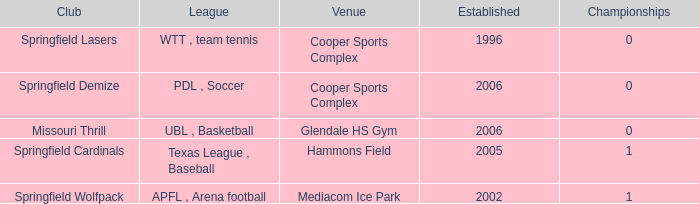What are the highest championships where the club is Springfield Cardinals? 1.0. 